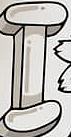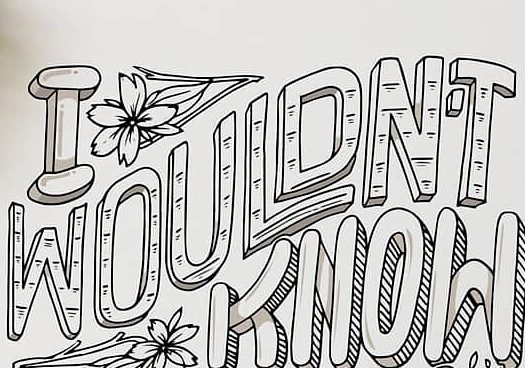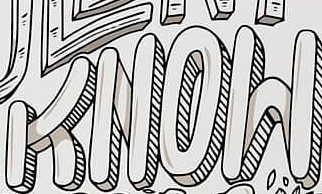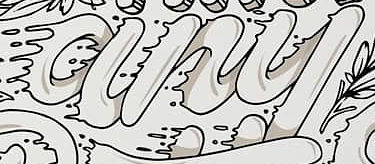What words are shown in these images in order, separated by a semicolon? I; WOULDN'T; KNOW; any 